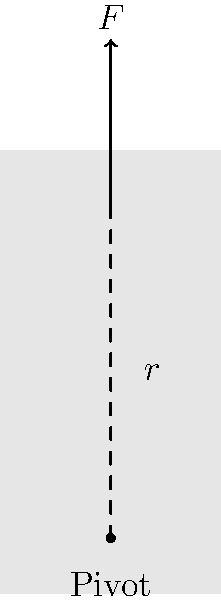During a powerful shot, a young player generates a force $F$ of 500 N at the core muscles, applied at a distance $r$ of 0.3 m from the pivot point at the base of the spine. Calculate the torque produced about this pivot point. How might understanding this concept help in developing more powerful shots, similar to those of Zlatan Ibrahimović? To solve this problem and understand its relevance to powerful shots, let's follow these steps:

1) The formula for torque is:
   $$\tau = F \cdot r \cdot \sin\theta$$
   where $\tau$ is torque, $F$ is force, $r$ is the distance from the pivot point to where the force is applied, and $\theta$ is the angle between the force vector and the radius vector.

2) In this case, the force is perpendicular to the radius, so $\sin\theta = 1$. This simplifies our equation to:
   $$\tau = F \cdot r$$

3) We're given:
   $F = 500$ N
   $r = 0.3$ m

4) Plugging these values into our equation:
   $$\tau = 500 \text{ N} \cdot 0.3 \text{ m} = 150 \text{ N}\cdot\text{m}$$

5) Understanding this concept can help develop more powerful shots because:
   a) It shows the importance of core strength in generating rotational force.
   b) It illustrates how a longer "lever arm" (distance from pivot) can increase torque.
   c) It emphasizes the role of technique in applying force perpendicular to the body's axis.

6) Zlatan Ibrahimović is known for his powerful shots. His technique likely maximizes torque by:
   a) Developing strong core muscles to increase force.
   b) Using a full range of motion to increase the effective radius.
   c) Applying force at the optimal angle to maximize torque.

By understanding and applying these principles, young players can work on developing more powerful and effective shots.
Answer: 150 N⋅m 